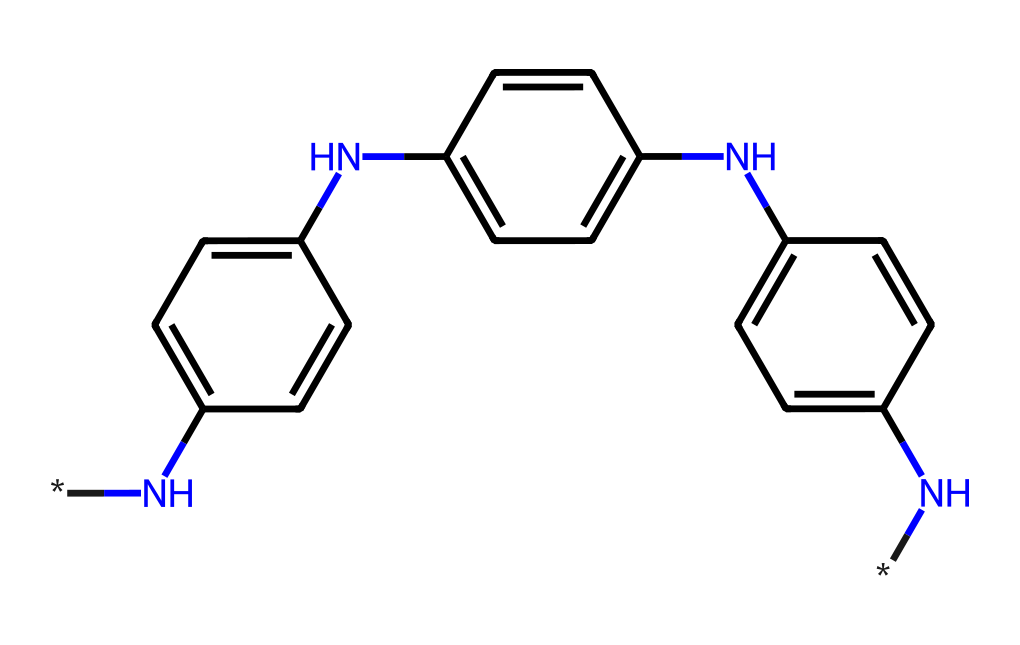What is the main functional group present in this chemical? The chemical contains multiple amine groups (indicated by the nitrogen atoms, especially the N groups at the ends of the structure). These amines serve as functional groups critical for photoreactivity.
Answer: amine How many benzene rings are in the structure? By analyzing the chemical's structure, it is evident there are three distinct benzene rings, each contributing to the stability and photochemical properties of the polymer.
Answer: three What is the total number of nitrogen atoms in the chemical? The structure shows four nitrogen atoms present, which can be counted by identifying each instance of 'N' in the SMILES representation.
Answer: four Which part of the chemical structure is likely responsible for light absorption? The benzene rings and the attached amine groups likely play a key role in light absorption. The conjugated pi-system in these rings enhances the compound's ability to absorb photons.
Answer: benzene rings What type of polymer is represented by this chemical? The presence of multiple amine-containing structures along with the benzene rings indicates that it is likely a photoactive polymer, specifically designed for smart windows that adapt to varying light conditions.
Answer: photoactive polymer How many total carbon atoms are in the structure? Assessing the carbon atoms in the structure can be done by counting all carbon positions linked to other atoms within the benzene rings. There are a total of eighteen carbon atoms present in this structure.
Answer: eighteen 